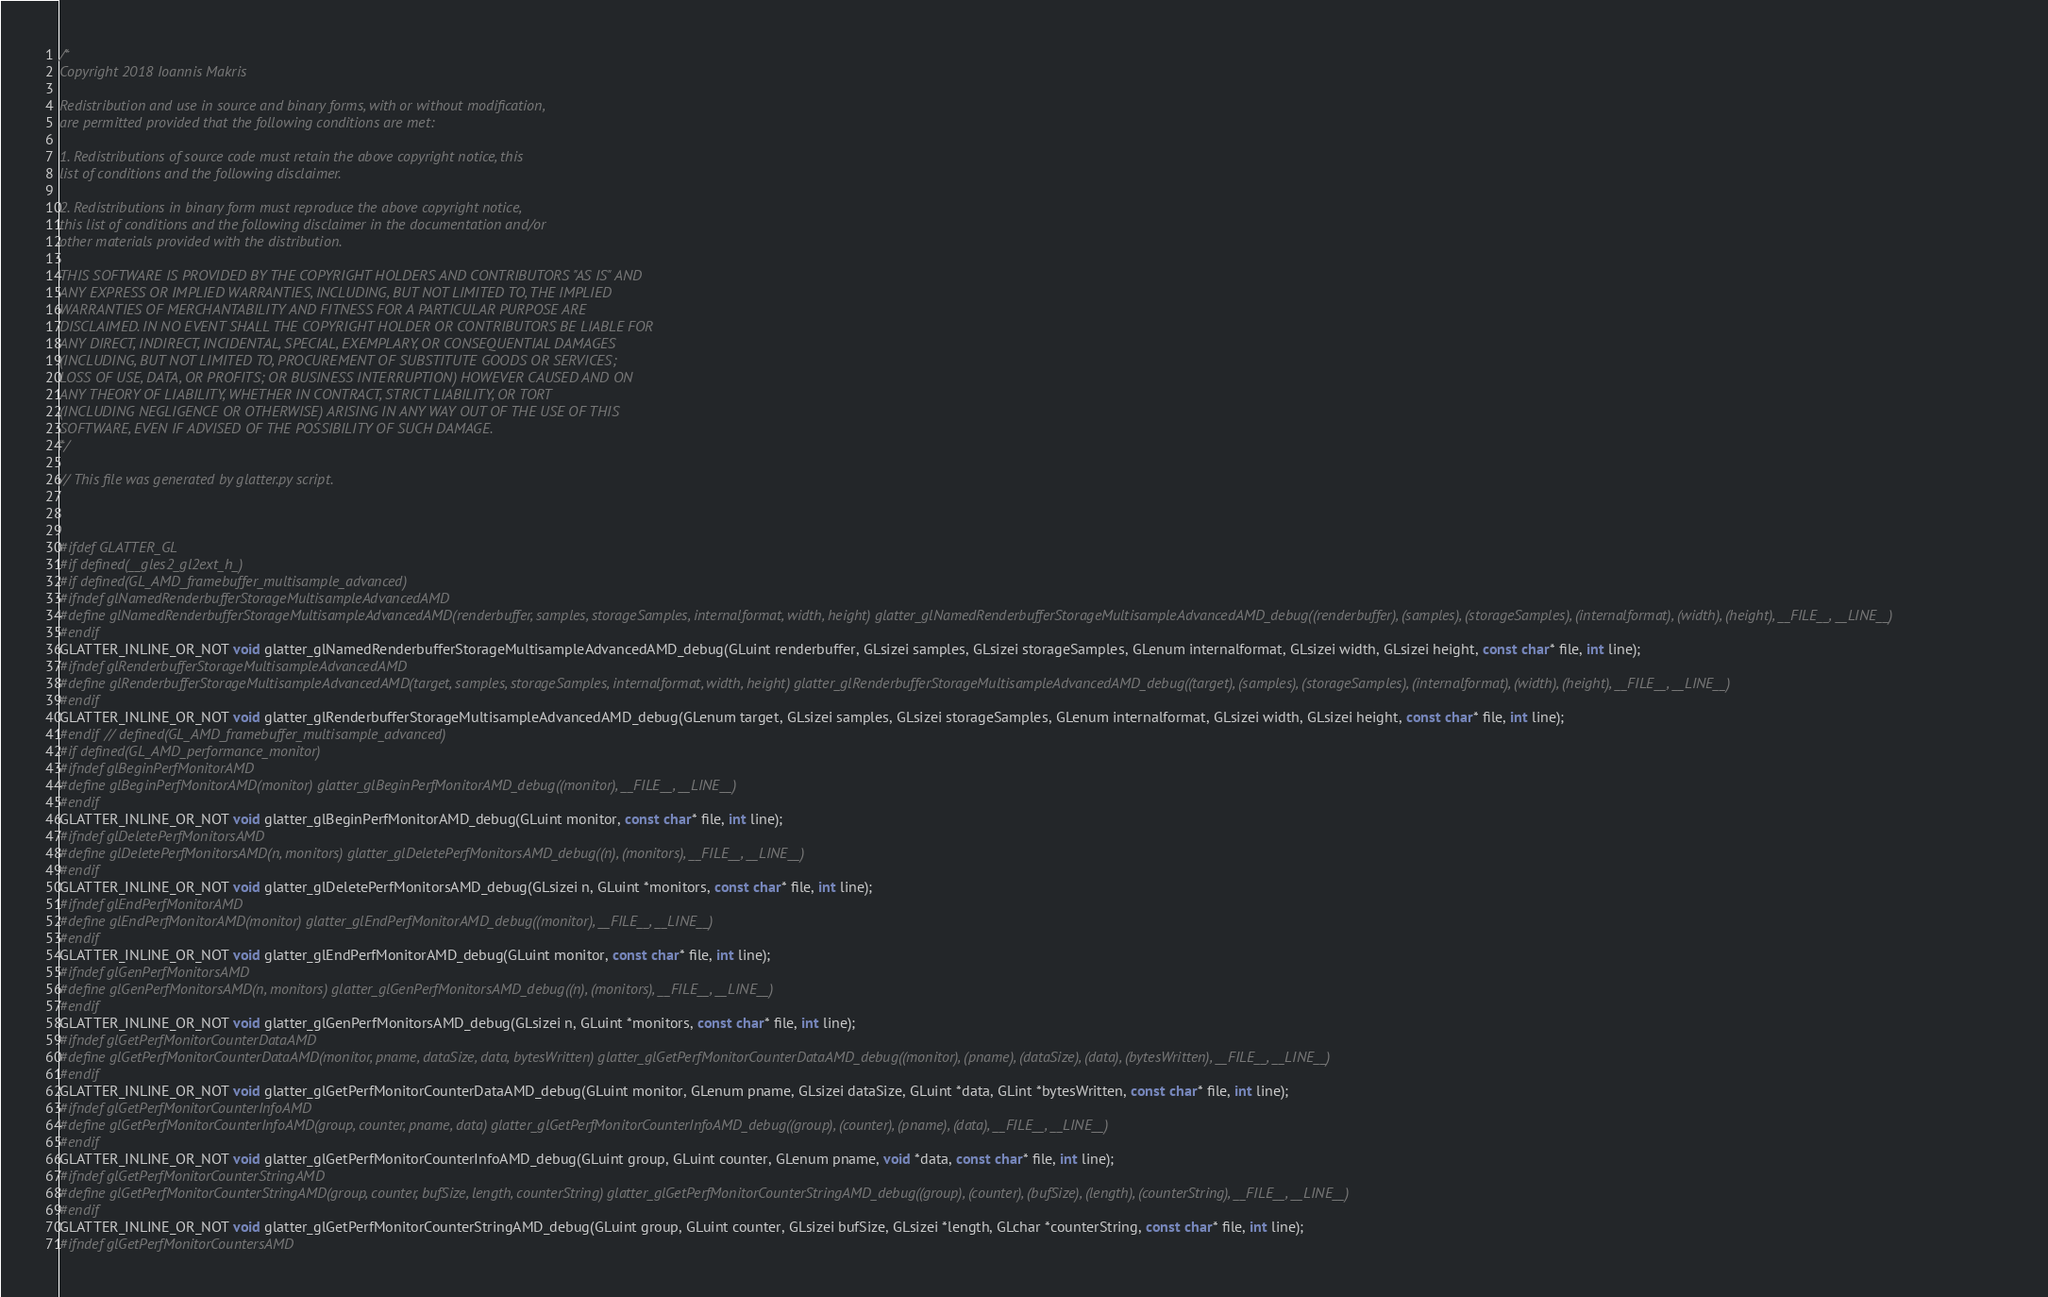<code> <loc_0><loc_0><loc_500><loc_500><_C_>/*
Copyright 2018 Ioannis Makris

Redistribution and use in source and binary forms, with or without modification,
are permitted provided that the following conditions are met:

1. Redistributions of source code must retain the above copyright notice, this
list of conditions and the following disclaimer.

2. Redistributions in binary form must reproduce the above copyright notice,
this list of conditions and the following disclaimer in the documentation and/or
other materials provided with the distribution.

THIS SOFTWARE IS PROVIDED BY THE COPYRIGHT HOLDERS AND CONTRIBUTORS "AS IS" AND
ANY EXPRESS OR IMPLIED WARRANTIES, INCLUDING, BUT NOT LIMITED TO, THE IMPLIED
WARRANTIES OF MERCHANTABILITY AND FITNESS FOR A PARTICULAR PURPOSE ARE
DISCLAIMED. IN NO EVENT SHALL THE COPYRIGHT HOLDER OR CONTRIBUTORS BE LIABLE FOR
ANY DIRECT, INDIRECT, INCIDENTAL, SPECIAL, EXEMPLARY, OR CONSEQUENTIAL DAMAGES
(INCLUDING, BUT NOT LIMITED TO, PROCUREMENT OF SUBSTITUTE GOODS OR SERVICES;
LOSS OF USE, DATA, OR PROFITS; OR BUSINESS INTERRUPTION) HOWEVER CAUSED AND ON
ANY THEORY OF LIABILITY, WHETHER IN CONTRACT, STRICT LIABILITY, OR TORT
(INCLUDING NEGLIGENCE OR OTHERWISE) ARISING IN ANY WAY OUT OF THE USE OF THIS
SOFTWARE, EVEN IF ADVISED OF THE POSSIBILITY OF SUCH DAMAGE.
*/

// This file was generated by glatter.py script.



#ifdef GLATTER_GL
#if defined(__gles2_gl2ext_h_)
#if defined(GL_AMD_framebuffer_multisample_advanced)
#ifndef glNamedRenderbufferStorageMultisampleAdvancedAMD
#define glNamedRenderbufferStorageMultisampleAdvancedAMD(renderbuffer, samples, storageSamples, internalformat, width, height) glatter_glNamedRenderbufferStorageMultisampleAdvancedAMD_debug((renderbuffer), (samples), (storageSamples), (internalformat), (width), (height), __FILE__, __LINE__)
#endif
GLATTER_INLINE_OR_NOT void glatter_glNamedRenderbufferStorageMultisampleAdvancedAMD_debug(GLuint renderbuffer, GLsizei samples, GLsizei storageSamples, GLenum internalformat, GLsizei width, GLsizei height, const char* file, int line);
#ifndef glRenderbufferStorageMultisampleAdvancedAMD
#define glRenderbufferStorageMultisampleAdvancedAMD(target, samples, storageSamples, internalformat, width, height) glatter_glRenderbufferStorageMultisampleAdvancedAMD_debug((target), (samples), (storageSamples), (internalformat), (width), (height), __FILE__, __LINE__)
#endif
GLATTER_INLINE_OR_NOT void glatter_glRenderbufferStorageMultisampleAdvancedAMD_debug(GLenum target, GLsizei samples, GLsizei storageSamples, GLenum internalformat, GLsizei width, GLsizei height, const char* file, int line);
#endif // defined(GL_AMD_framebuffer_multisample_advanced)
#if defined(GL_AMD_performance_monitor)
#ifndef glBeginPerfMonitorAMD
#define glBeginPerfMonitorAMD(monitor) glatter_glBeginPerfMonitorAMD_debug((monitor), __FILE__, __LINE__)
#endif
GLATTER_INLINE_OR_NOT void glatter_glBeginPerfMonitorAMD_debug(GLuint monitor, const char* file, int line);
#ifndef glDeletePerfMonitorsAMD
#define glDeletePerfMonitorsAMD(n, monitors) glatter_glDeletePerfMonitorsAMD_debug((n), (monitors), __FILE__, __LINE__)
#endif
GLATTER_INLINE_OR_NOT void glatter_glDeletePerfMonitorsAMD_debug(GLsizei n, GLuint *monitors, const char* file, int line);
#ifndef glEndPerfMonitorAMD
#define glEndPerfMonitorAMD(monitor) glatter_glEndPerfMonitorAMD_debug((monitor), __FILE__, __LINE__)
#endif
GLATTER_INLINE_OR_NOT void glatter_glEndPerfMonitorAMD_debug(GLuint monitor, const char* file, int line);
#ifndef glGenPerfMonitorsAMD
#define glGenPerfMonitorsAMD(n, monitors) glatter_glGenPerfMonitorsAMD_debug((n), (monitors), __FILE__, __LINE__)
#endif
GLATTER_INLINE_OR_NOT void glatter_glGenPerfMonitorsAMD_debug(GLsizei n, GLuint *monitors, const char* file, int line);
#ifndef glGetPerfMonitorCounterDataAMD
#define glGetPerfMonitorCounterDataAMD(monitor, pname, dataSize, data, bytesWritten) glatter_glGetPerfMonitorCounterDataAMD_debug((monitor), (pname), (dataSize), (data), (bytesWritten), __FILE__, __LINE__)
#endif
GLATTER_INLINE_OR_NOT void glatter_glGetPerfMonitorCounterDataAMD_debug(GLuint monitor, GLenum pname, GLsizei dataSize, GLuint *data, GLint *bytesWritten, const char* file, int line);
#ifndef glGetPerfMonitorCounterInfoAMD
#define glGetPerfMonitorCounterInfoAMD(group, counter, pname, data) glatter_glGetPerfMonitorCounterInfoAMD_debug((group), (counter), (pname), (data), __FILE__, __LINE__)
#endif
GLATTER_INLINE_OR_NOT void glatter_glGetPerfMonitorCounterInfoAMD_debug(GLuint group, GLuint counter, GLenum pname, void *data, const char* file, int line);
#ifndef glGetPerfMonitorCounterStringAMD
#define glGetPerfMonitorCounterStringAMD(group, counter, bufSize, length, counterString) glatter_glGetPerfMonitorCounterStringAMD_debug((group), (counter), (bufSize), (length), (counterString), __FILE__, __LINE__)
#endif
GLATTER_INLINE_OR_NOT void glatter_glGetPerfMonitorCounterStringAMD_debug(GLuint group, GLuint counter, GLsizei bufSize, GLsizei *length, GLchar *counterString, const char* file, int line);
#ifndef glGetPerfMonitorCountersAMD</code> 